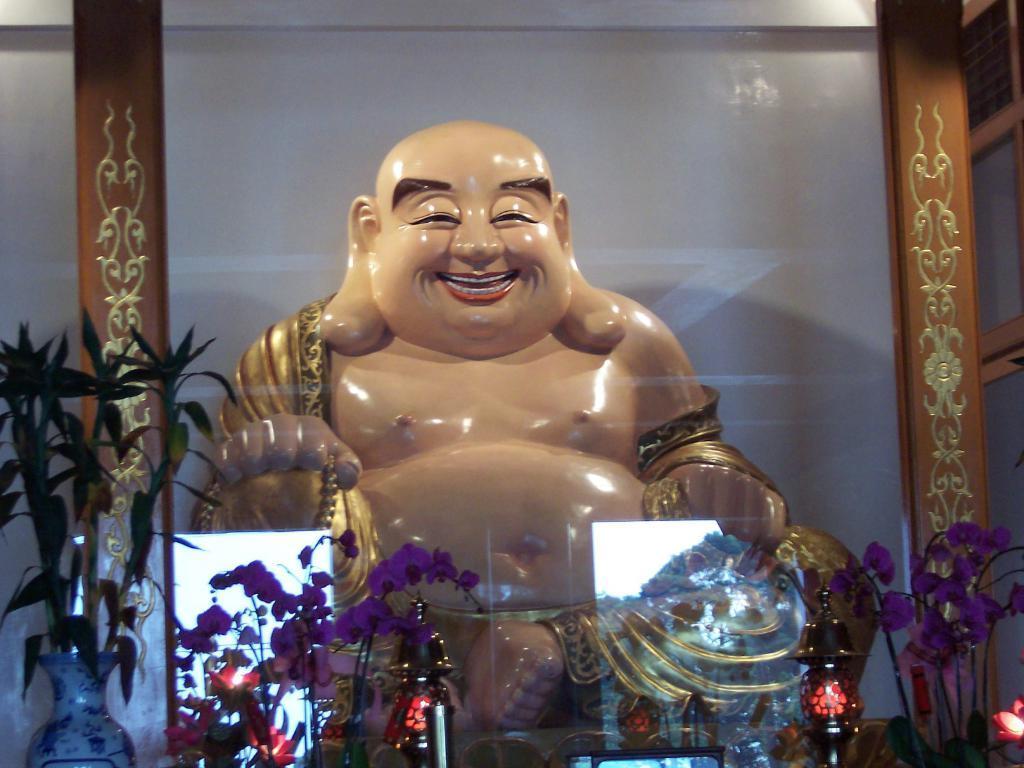Describe this image in one or two sentences. In this image we can see a statue in a transparent glass, beside that we can see artificial flowers and plants. And we can see a few objects. 